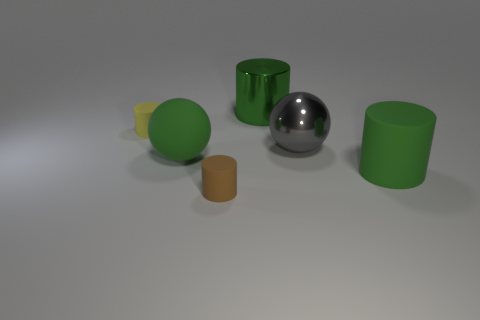Subtract all cyan cylinders. Subtract all brown balls. How many cylinders are left? 4 Add 4 big green metallic things. How many objects exist? 10 Subtract all cylinders. How many objects are left? 2 Add 3 big gray objects. How many big gray objects exist? 4 Subtract 1 yellow cylinders. How many objects are left? 5 Subtract all brown cylinders. Subtract all brown rubber cylinders. How many objects are left? 4 Add 2 green spheres. How many green spheres are left? 3 